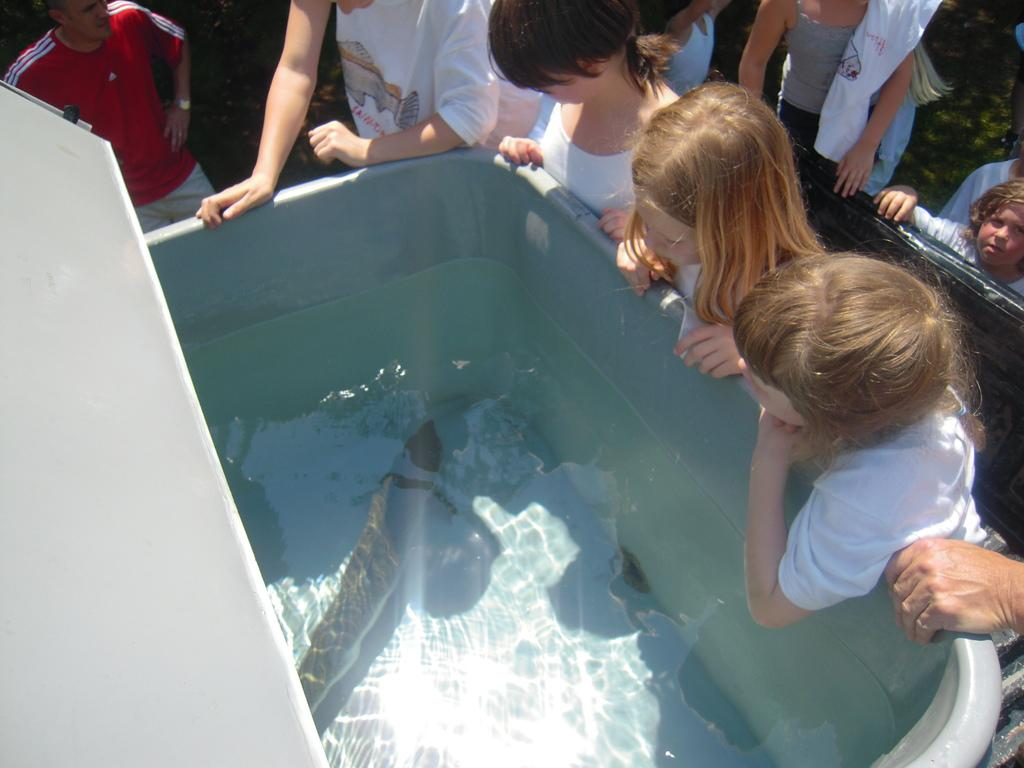Who is present in the image? There are children and people in the image. What are they doing in the image? They are standing over a place. What object can be seen in the image? There is a tub present in the image. What is inside the tub? There is water in the tub. What can be found in the water? There are fishes in the water. How many sheep can be seen grazing in the image? There are no sheep present in the image. What type of vein is visible in the image? There is no vein visible in the image. 